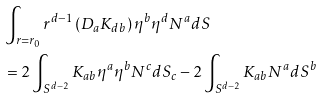Convert formula to latex. <formula><loc_0><loc_0><loc_500><loc_500>& \int _ { r = r _ { 0 } } r ^ { d - 1 } \left ( D _ { a } K _ { d b } \right ) \eta ^ { b } \eta ^ { d } N ^ { a } d S \\ & = 2 \int _ { S ^ { d - 2 } } K _ { a b } \eta ^ { a } \eta ^ { b } N ^ { c } d S _ { c } - 2 \int _ { S ^ { d - 2 } } K _ { a b } N ^ { a } d S ^ { b }</formula> 